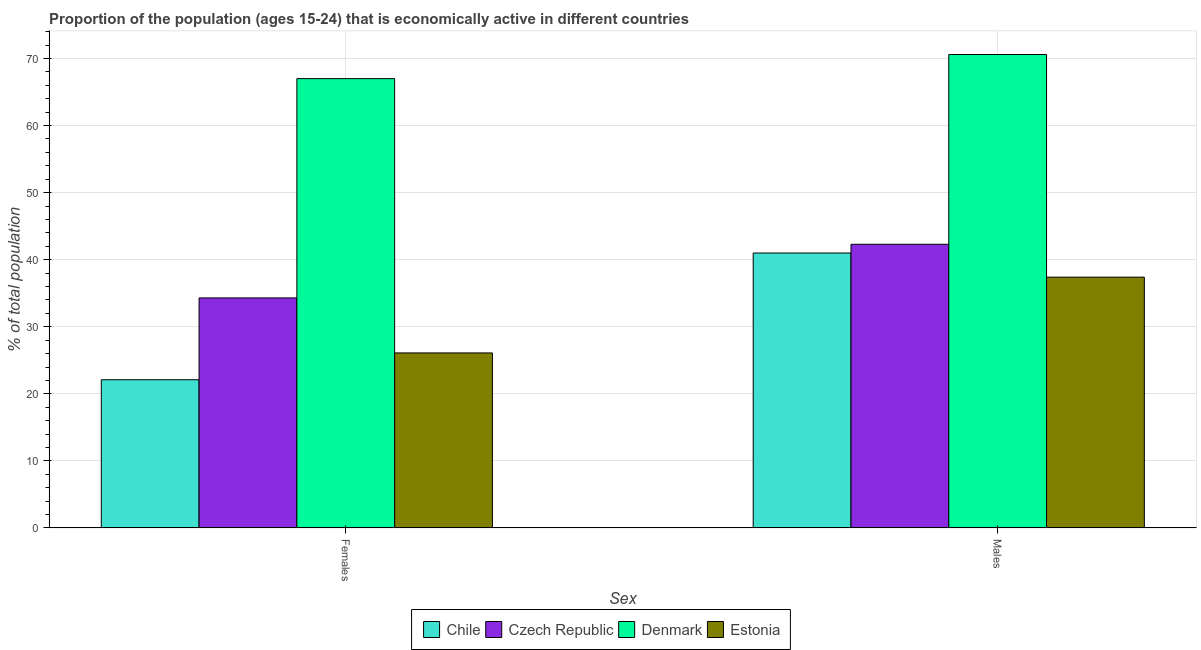How many groups of bars are there?
Ensure brevity in your answer.  2. Are the number of bars per tick equal to the number of legend labels?
Offer a terse response. Yes. How many bars are there on the 1st tick from the left?
Offer a very short reply. 4. How many bars are there on the 2nd tick from the right?
Your answer should be very brief. 4. What is the label of the 1st group of bars from the left?
Ensure brevity in your answer.  Females. Across all countries, what is the minimum percentage of economically active female population?
Provide a short and direct response. 22.1. In which country was the percentage of economically active male population minimum?
Offer a very short reply. Estonia. What is the total percentage of economically active female population in the graph?
Offer a very short reply. 149.5. What is the difference between the percentage of economically active male population in Chile and that in Denmark?
Your answer should be very brief. -29.6. What is the difference between the percentage of economically active male population in Estonia and the percentage of economically active female population in Denmark?
Offer a terse response. -29.6. What is the average percentage of economically active male population per country?
Keep it short and to the point. 47.82. What is the difference between the percentage of economically active male population and percentage of economically active female population in Chile?
Offer a very short reply. 18.9. In how many countries, is the percentage of economically active female population greater than 36 %?
Keep it short and to the point. 1. What is the ratio of the percentage of economically active female population in Denmark to that in Czech Republic?
Your answer should be compact. 1.95. Is the percentage of economically active female population in Estonia less than that in Chile?
Your response must be concise. No. In how many countries, is the percentage of economically active female population greater than the average percentage of economically active female population taken over all countries?
Provide a short and direct response. 1. What does the 2nd bar from the left in Males represents?
Provide a succinct answer. Czech Republic. Are the values on the major ticks of Y-axis written in scientific E-notation?
Keep it short and to the point. No. Does the graph contain grids?
Your answer should be very brief. Yes. Where does the legend appear in the graph?
Your response must be concise. Bottom center. How many legend labels are there?
Ensure brevity in your answer.  4. How are the legend labels stacked?
Give a very brief answer. Horizontal. What is the title of the graph?
Your answer should be very brief. Proportion of the population (ages 15-24) that is economically active in different countries. Does "Antigua and Barbuda" appear as one of the legend labels in the graph?
Give a very brief answer. No. What is the label or title of the X-axis?
Give a very brief answer. Sex. What is the label or title of the Y-axis?
Offer a very short reply. % of total population. What is the % of total population in Chile in Females?
Give a very brief answer. 22.1. What is the % of total population in Czech Republic in Females?
Give a very brief answer. 34.3. What is the % of total population in Estonia in Females?
Your response must be concise. 26.1. What is the % of total population in Chile in Males?
Offer a terse response. 41. What is the % of total population of Czech Republic in Males?
Your answer should be compact. 42.3. What is the % of total population of Denmark in Males?
Keep it short and to the point. 70.6. What is the % of total population in Estonia in Males?
Offer a very short reply. 37.4. Across all Sex, what is the maximum % of total population of Czech Republic?
Ensure brevity in your answer.  42.3. Across all Sex, what is the maximum % of total population of Denmark?
Your response must be concise. 70.6. Across all Sex, what is the maximum % of total population in Estonia?
Ensure brevity in your answer.  37.4. Across all Sex, what is the minimum % of total population of Chile?
Make the answer very short. 22.1. Across all Sex, what is the minimum % of total population in Czech Republic?
Ensure brevity in your answer.  34.3. Across all Sex, what is the minimum % of total population of Estonia?
Your answer should be very brief. 26.1. What is the total % of total population of Chile in the graph?
Offer a terse response. 63.1. What is the total % of total population in Czech Republic in the graph?
Your answer should be very brief. 76.6. What is the total % of total population of Denmark in the graph?
Your response must be concise. 137.6. What is the total % of total population in Estonia in the graph?
Your response must be concise. 63.5. What is the difference between the % of total population of Chile in Females and that in Males?
Provide a succinct answer. -18.9. What is the difference between the % of total population in Chile in Females and the % of total population in Czech Republic in Males?
Keep it short and to the point. -20.2. What is the difference between the % of total population in Chile in Females and the % of total population in Denmark in Males?
Offer a very short reply. -48.5. What is the difference between the % of total population of Chile in Females and the % of total population of Estonia in Males?
Make the answer very short. -15.3. What is the difference between the % of total population of Czech Republic in Females and the % of total population of Denmark in Males?
Your answer should be very brief. -36.3. What is the difference between the % of total population of Czech Republic in Females and the % of total population of Estonia in Males?
Provide a succinct answer. -3.1. What is the difference between the % of total population in Denmark in Females and the % of total population in Estonia in Males?
Your response must be concise. 29.6. What is the average % of total population in Chile per Sex?
Provide a succinct answer. 31.55. What is the average % of total population in Czech Republic per Sex?
Ensure brevity in your answer.  38.3. What is the average % of total population of Denmark per Sex?
Ensure brevity in your answer.  68.8. What is the average % of total population of Estonia per Sex?
Keep it short and to the point. 31.75. What is the difference between the % of total population in Chile and % of total population in Czech Republic in Females?
Ensure brevity in your answer.  -12.2. What is the difference between the % of total population in Chile and % of total population in Denmark in Females?
Your response must be concise. -44.9. What is the difference between the % of total population in Czech Republic and % of total population in Denmark in Females?
Keep it short and to the point. -32.7. What is the difference between the % of total population in Denmark and % of total population in Estonia in Females?
Make the answer very short. 40.9. What is the difference between the % of total population of Chile and % of total population of Denmark in Males?
Ensure brevity in your answer.  -29.6. What is the difference between the % of total population of Czech Republic and % of total population of Denmark in Males?
Your answer should be compact. -28.3. What is the difference between the % of total population in Denmark and % of total population in Estonia in Males?
Offer a terse response. 33.2. What is the ratio of the % of total population in Chile in Females to that in Males?
Your response must be concise. 0.54. What is the ratio of the % of total population of Czech Republic in Females to that in Males?
Make the answer very short. 0.81. What is the ratio of the % of total population in Denmark in Females to that in Males?
Offer a very short reply. 0.95. What is the ratio of the % of total population in Estonia in Females to that in Males?
Offer a terse response. 0.7. What is the difference between the highest and the second highest % of total population of Estonia?
Your response must be concise. 11.3. What is the difference between the highest and the lowest % of total population of Chile?
Make the answer very short. 18.9. What is the difference between the highest and the lowest % of total population in Czech Republic?
Your answer should be very brief. 8. What is the difference between the highest and the lowest % of total population of Denmark?
Provide a short and direct response. 3.6. What is the difference between the highest and the lowest % of total population of Estonia?
Your response must be concise. 11.3. 